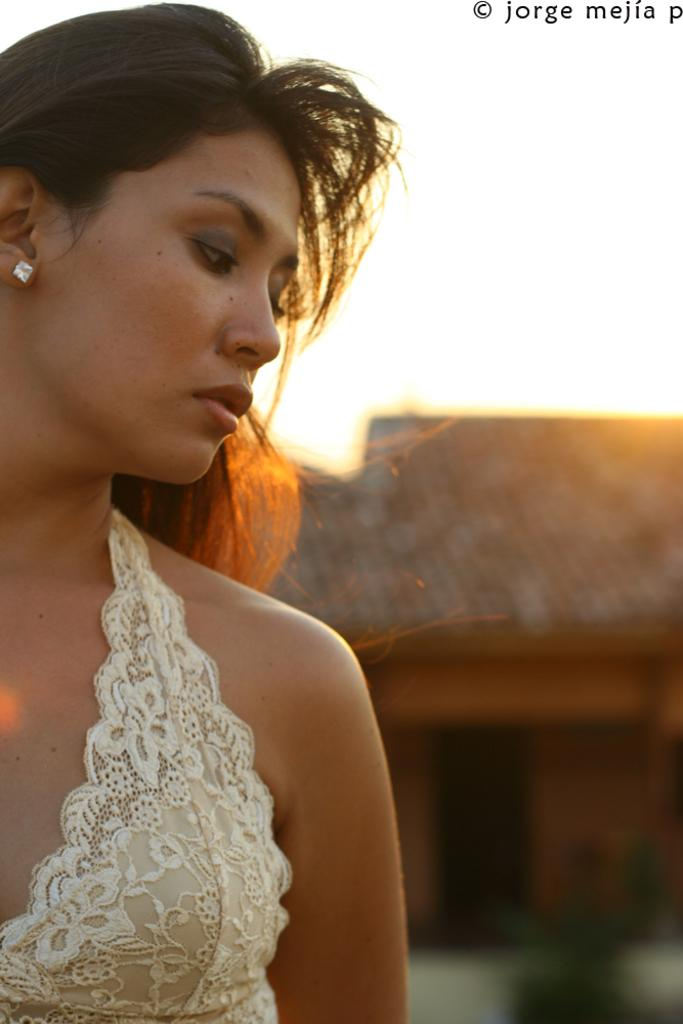Who is the main subject in the image? There is a woman in the image. What is the woman wearing? The woman is wearing a white dress. What type of structure can be seen in the image? There is a house in the image. What can be seen in the background of the image? The sky is visible in the background of the image. What is written or displayed at the top of the image? There is some text at the top of the image. What is the dog's reaction to the woman in the image? There is no dog present in the image, so it is not possible to determine the dog's reaction. 